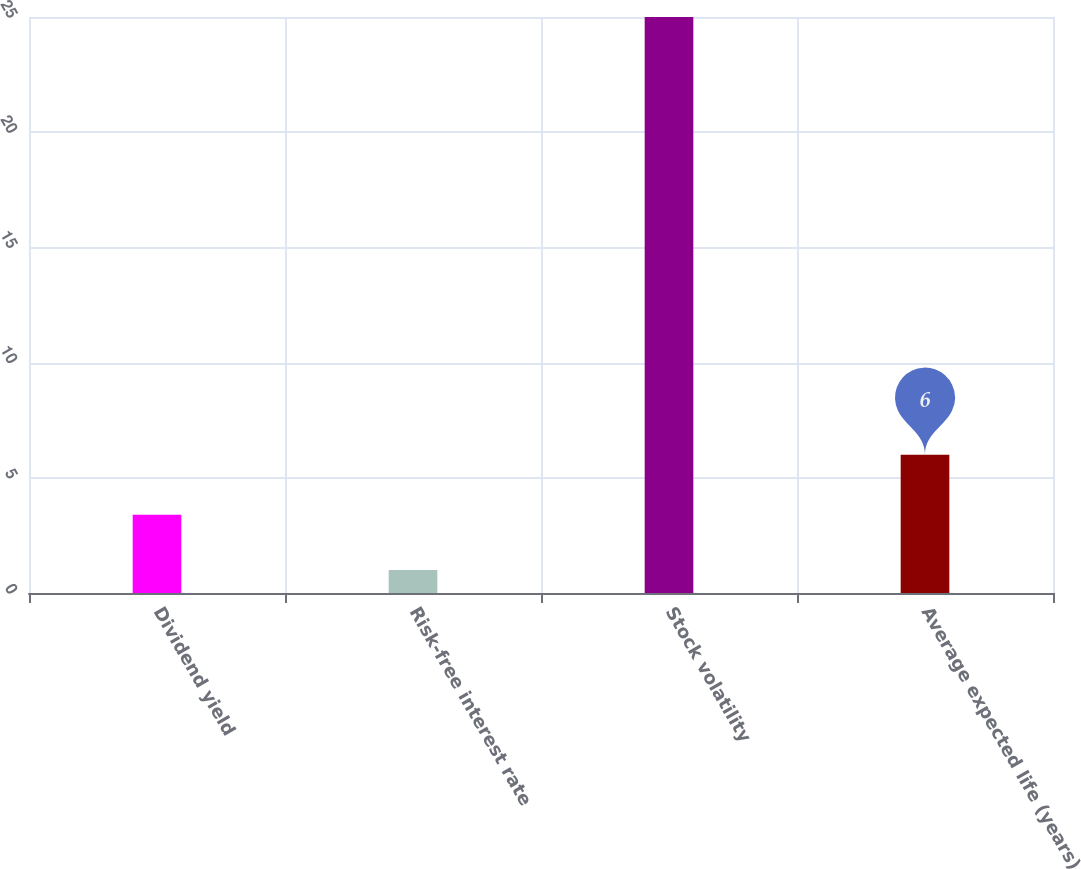Convert chart. <chart><loc_0><loc_0><loc_500><loc_500><bar_chart><fcel>Dividend yield<fcel>Risk-free interest rate<fcel>Stock volatility<fcel>Average expected life (years)<nl><fcel>3.4<fcel>1<fcel>25<fcel>6<nl></chart> 